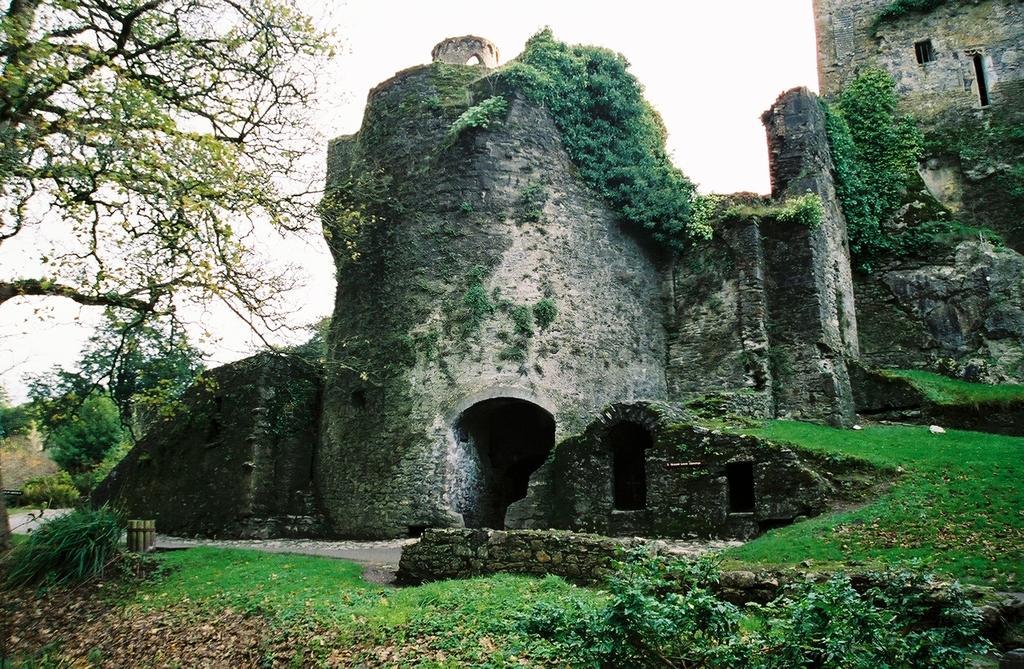In one or two sentences, can you explain what this image depicts? In the foreground of this image, on the bottom, there are plants and the grass on the ground. On the left, there is a tree. In the background, there is a stone castle and plants on it. On the top, there is the sky. 